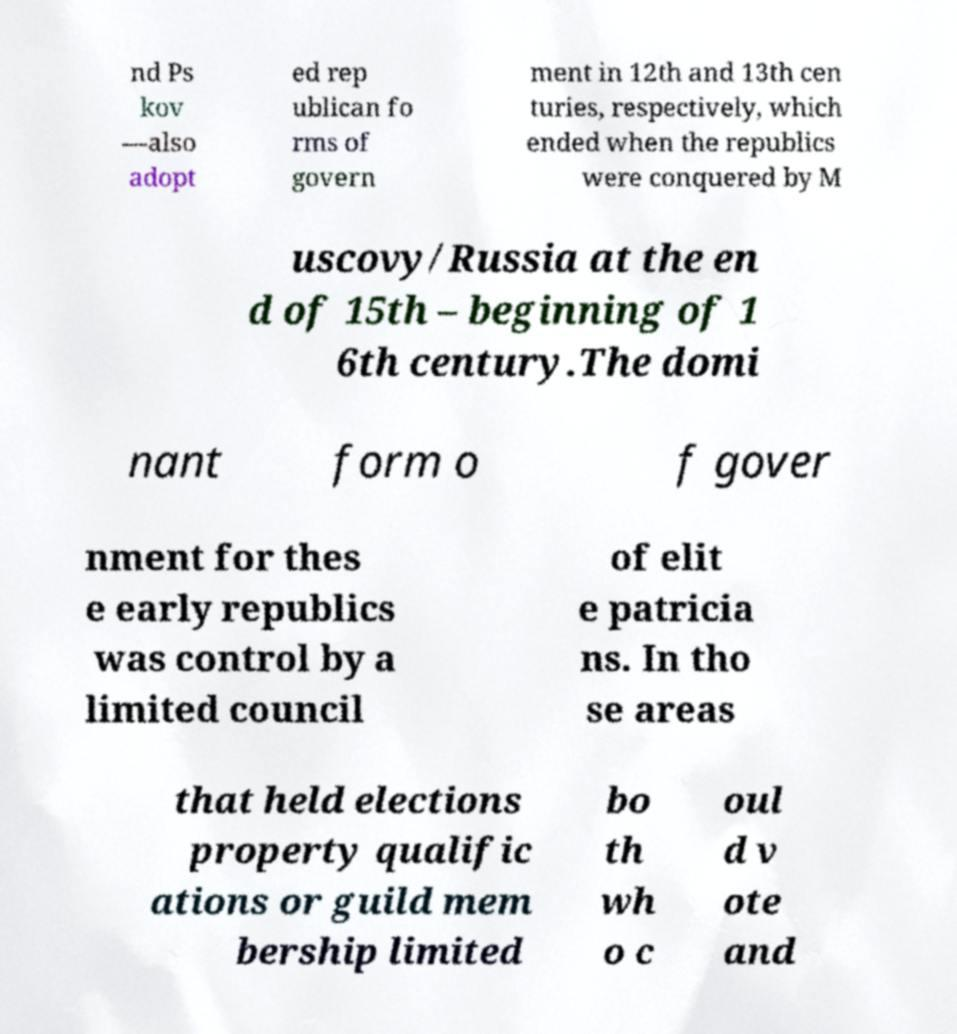Can you read and provide the text displayed in the image?This photo seems to have some interesting text. Can you extract and type it out for me? nd Ps kov —also adopt ed rep ublican fo rms of govern ment in 12th and 13th cen turies, respectively, which ended when the republics were conquered by M uscovy/Russia at the en d of 15th – beginning of 1 6th century.The domi nant form o f gover nment for thes e early republics was control by a limited council of elit e patricia ns. In tho se areas that held elections property qualific ations or guild mem bership limited bo th wh o c oul d v ote and 